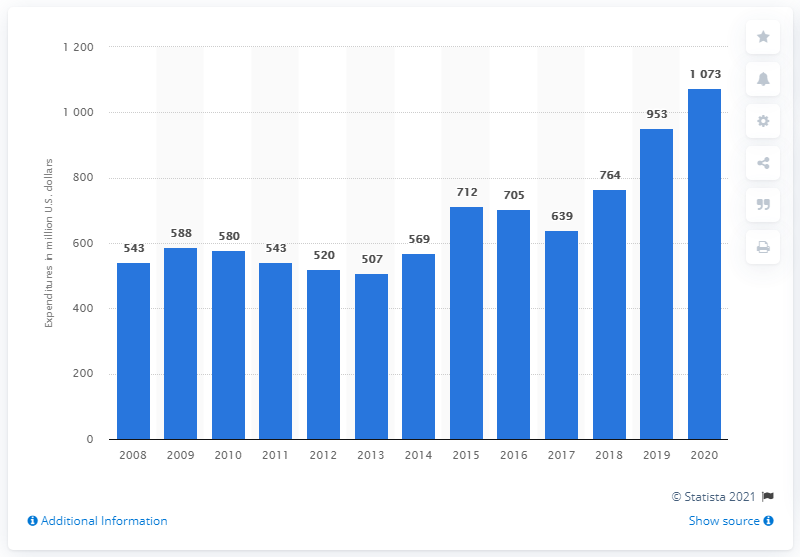Outline some significant characteristics in this image. Northrop Grumman's research and development expenditures were first reported in 2008. In the 2020 fiscal year, Northrop Grumman reported spending $107.3 million on research and development. 